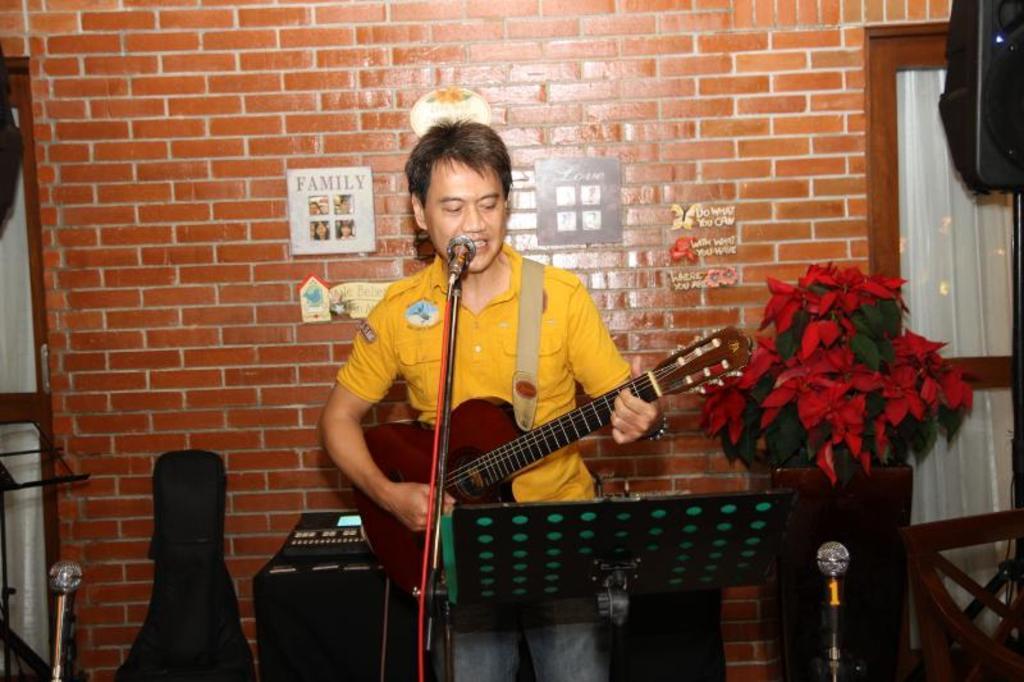How would you summarize this image in a sentence or two? In this picture there is a person, who is singing and playing a guitar. On his back side there is a brick wall having family photo frame and cards. On right side there is a door and a speaker. Here it's a guitar bag. There are three mics here. There is a Plant. 